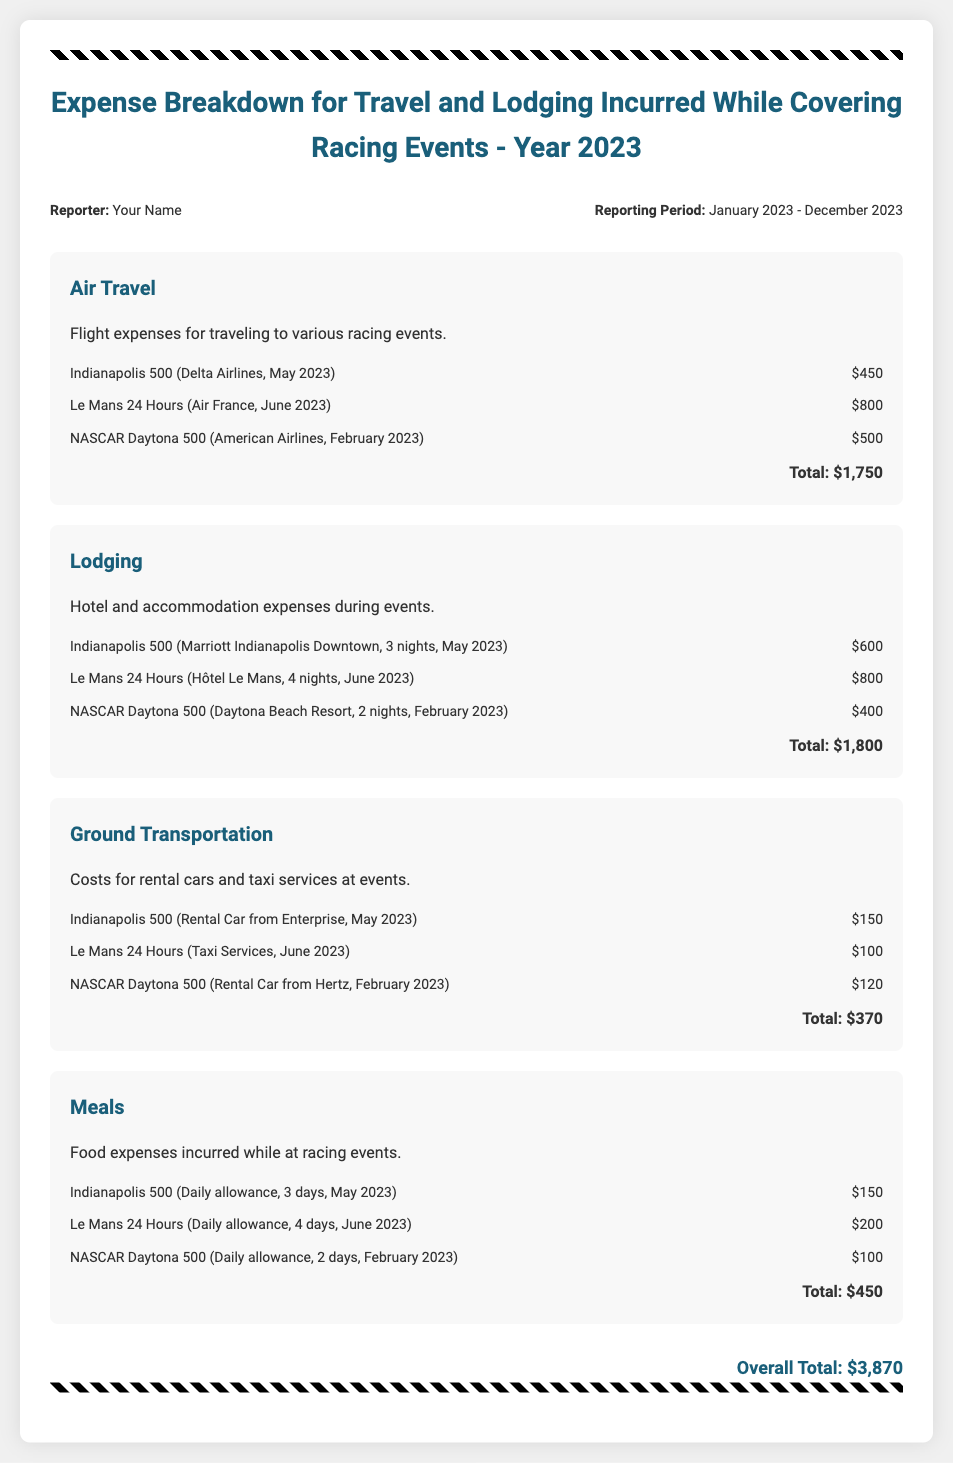What is the total expense for Air Travel? The total expense for Air Travel is given in the Air Travel section, which sums up to $1,750.
Answer: $1,750 What event incurred the highest lodging expense? The lodging expenses detail shows that the Le Mans 24 Hours incurred the highest cost of $800.
Answer: Le Mans 24 Hours How much was spent on Ground Transportation? The Ground Transportation section lists the total expenditure as $370.
Answer: $370 What is the overall total of all expenses? The overall total is calculated from the sum of all categories, which amounts to $3,870.
Answer: $3,870 Which airline was used for the Indianapolis 500? The document specifies that Delta Airlines was used for the Indianapolis 500 flight.
Answer: Delta Airlines What type of lodging was used for the Daytona 500? The lodging for the Daytona 500 was at Daytona Beach Resort, as mentioned in the report.
Answer: Daytona Beach Resort Calculate the total food expenses for the year. The total food expenses are detailed in the Meals section, totaling $450.
Answer: $450 Which transport company was used for the rental car at the Indianapolis 500? The rental car at the Indianapolis 500 was from Enterprise, as stated in the document.
Answer: Enterprise How many nights were spent at the hotel during the Le Mans 24 Hours? The lodging section shows that 4 nights were spent at the hotel during the Le Mans 24 Hours event.
Answer: 4 nights 